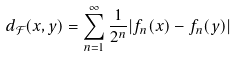<formula> <loc_0><loc_0><loc_500><loc_500>d _ { \mathcal { F } } ( x , y ) = \sum _ { n = 1 } ^ { \infty } \frac { 1 } { 2 ^ { n } } | f _ { n } ( x ) - f _ { n } ( y ) |</formula> 